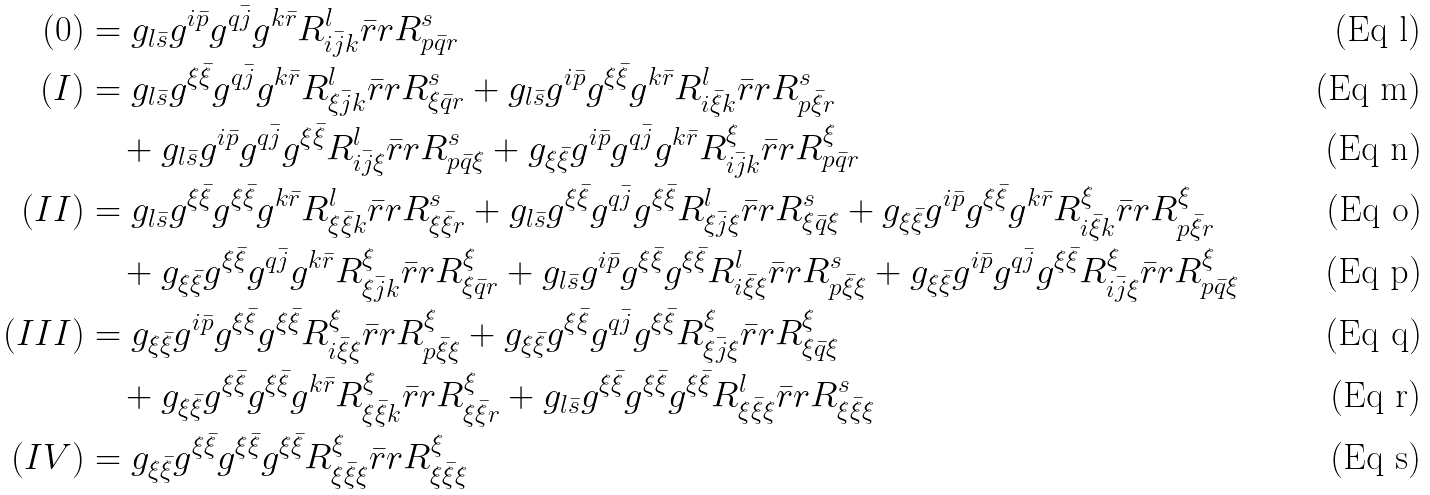<formula> <loc_0><loc_0><loc_500><loc_500>( 0 ) & = g _ { l \bar { s } } g ^ { i \bar { p } } g ^ { q \bar { j } } g ^ { k \bar { r } } R _ { i \bar { j } k } ^ { l } \bar { r } r { R _ { p \bar { q } r } ^ { s } } \\ ( I ) & = g _ { l \bar { s } } g ^ { \xi \bar { \xi } } g ^ { q \bar { j } } g ^ { k \bar { r } } R _ { \xi \bar { j } k } ^ { l } \bar { r } r { R _ { \xi \bar { q } r } ^ { s } } + g _ { l \bar { s } } g ^ { i \bar { p } } g ^ { \xi \bar { \xi } } g ^ { k \bar { r } } R _ { i \bar { \xi } k } ^ { l } \bar { r } r { R _ { p \bar { \xi } r } ^ { s } } \\ & \quad + g _ { l \bar { s } } g ^ { i \bar { p } } g ^ { q \bar { j } } g ^ { \xi \bar { \xi } } R _ { i \bar { j } \xi } ^ { l } \bar { r } r { R _ { p \bar { q } \xi } ^ { s } } + g _ { \xi \bar { \xi } } g ^ { i \bar { p } } g ^ { q \bar { j } } g ^ { k \bar { r } } R _ { i \bar { j } k } ^ { \xi } \bar { r } r { R _ { p \bar { q } r } ^ { \xi } } \\ ( I I ) & = g _ { l \bar { s } } g ^ { \xi \bar { \xi } } g ^ { \xi \bar { \xi } } g ^ { k \bar { r } } R _ { \xi \bar { \xi } k } ^ { l } \bar { r } r { R _ { \xi \bar { \xi } r } ^ { s } } + g _ { l \bar { s } } g ^ { \xi \bar { \xi } } g ^ { q \bar { j } } g ^ { \xi \bar { \xi } } R _ { \xi \bar { j } \xi } ^ { l } \bar { r } r { R _ { \xi \bar { q } \xi } ^ { s } } + g _ { \xi \bar { \xi } } g ^ { i \bar { p } } g ^ { \xi \bar { \xi } } g ^ { k \bar { r } } R _ { i \bar { \xi } k } ^ { \xi } \bar { r } r { R _ { p \bar { \xi } r } ^ { \xi } } \\ & \quad + g _ { \xi \bar { \xi } } g ^ { \xi \bar { \xi } } g ^ { q \bar { j } } g ^ { k \bar { r } } R _ { \xi \bar { j } k } ^ { \xi } \bar { r } r { R _ { \xi \bar { q } r } ^ { \xi } } + g _ { l \bar { s } } g ^ { i \bar { p } } g ^ { \xi \bar { \xi } } g ^ { \xi \bar { \xi } } R _ { i \bar { \xi } \xi } ^ { l } \bar { r } r { R _ { p \bar { \xi } \xi } ^ { s } } + g _ { \xi \bar { \xi } } g ^ { i \bar { p } } g ^ { q \bar { j } } g ^ { \xi \bar { \xi } } R _ { i \bar { j } \xi } ^ { \xi } \bar { r } r { R _ { p \bar { q } \xi } ^ { \xi } } \\ ( I I I ) & = g _ { \xi \bar { \xi } } g ^ { i \bar { p } } g ^ { \xi \bar { \xi } } g ^ { \xi \bar { \xi } } R _ { i \bar { \xi } \xi } ^ { \xi } \bar { r } r { R _ { p \bar { \xi } \xi } ^ { \xi } } + g _ { \xi \bar { \xi } } g ^ { \xi \bar { \xi } } g ^ { q \bar { j } } g ^ { \xi \bar { \xi } } R _ { \xi \bar { j } \xi } ^ { \xi } \bar { r } r { R _ { \xi \bar { q } \xi } ^ { \xi } } \\ & \quad + g _ { \xi \bar { \xi } } g ^ { \xi \bar { \xi } } g ^ { \xi \bar { \xi } } g ^ { k \bar { r } } R _ { \xi \bar { \xi } k } ^ { \xi } \bar { r } r { R _ { \xi \bar { \xi } r } ^ { \xi } } + g _ { l \bar { s } } g ^ { \xi \bar { \xi } } g ^ { \xi \bar { \xi } } g ^ { \xi \bar { \xi } } R _ { \xi \bar { \xi } \xi } ^ { l } \bar { r } r { R _ { \xi \bar { \xi } \xi } ^ { s } } \\ ( I V ) & = g _ { \xi \bar { \xi } } g ^ { \xi \bar { \xi } } g ^ { \xi \bar { \xi } } g ^ { \xi \bar { \xi } } R _ { \xi \bar { \xi } \xi } ^ { \xi } \bar { r } r { R _ { \xi \bar { \xi } \xi } ^ { \xi } }</formula> 